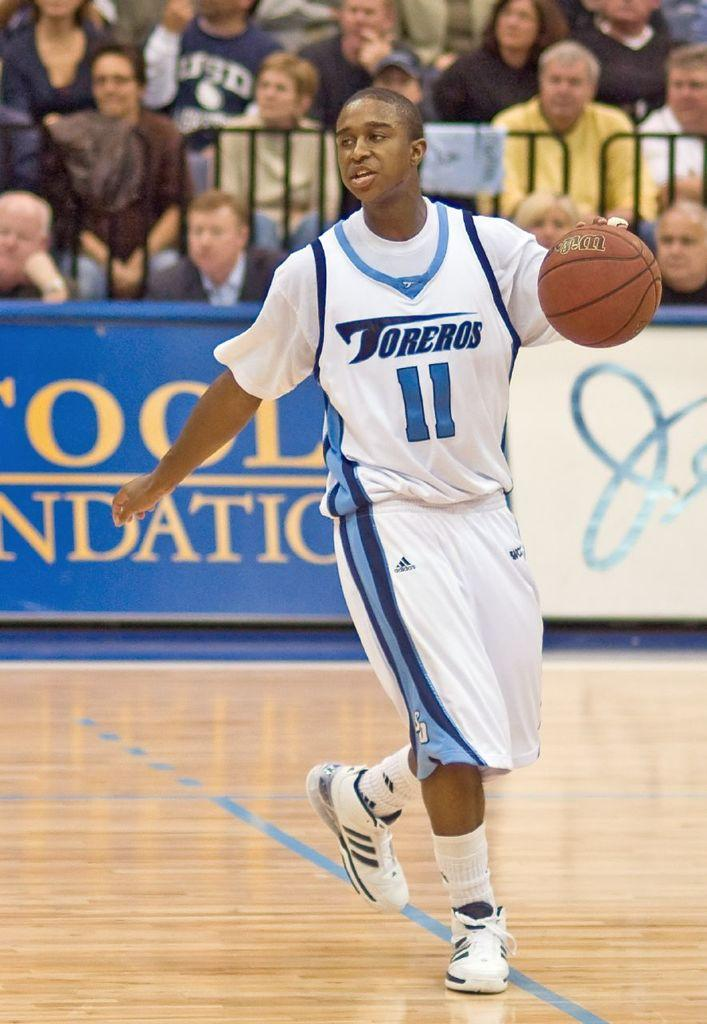<image>
Summarize the visual content of the image. Basketball player number eleven playing for Torreros on the court 